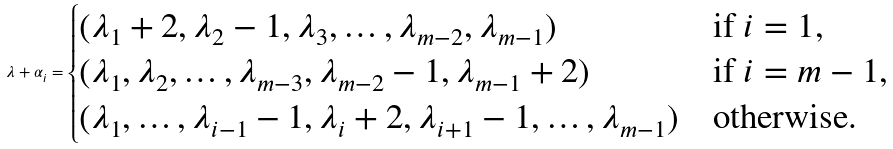Convert formula to latex. <formula><loc_0><loc_0><loc_500><loc_500>\lambda + \alpha _ { i } = \begin{cases} ( \lambda _ { 1 } + 2 , \lambda _ { 2 } - 1 , \lambda _ { 3 } , \dots , \lambda _ { m - 2 } , \lambda _ { m - 1 } ) & \text {if $i=1$} , \\ ( \lambda _ { 1 } , \lambda _ { 2 } , \dots , \lambda _ { m - 3 } , \lambda _ { m - 2 } - 1 , \lambda _ { m - 1 } + 2 ) & \text {if $i=m-1$} , \\ ( \lambda _ { 1 } , \dots , \lambda _ { i - 1 } - 1 , \lambda _ { i } + 2 , \lambda _ { i + 1 } - 1 , \dots , \lambda _ { m - 1 } ) & \text {otherwise.} \end{cases}</formula> 